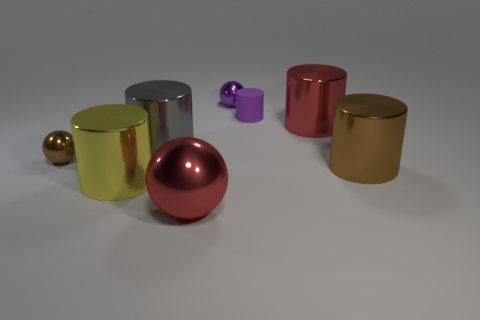What number of objects are either big gray things or big cylinders left of the purple shiny object?
Ensure brevity in your answer.  2. Are the sphere in front of the large brown metal cylinder and the purple cylinder made of the same material?
Offer a very short reply. No. What is the color of the shiny ball that is the same size as the yellow object?
Give a very brief answer. Red. Are there any red metal objects that have the same shape as the large gray object?
Your answer should be compact. Yes. There is a big cylinder that is in front of the brown metal object to the right of the ball that is in front of the yellow metal object; what color is it?
Offer a terse response. Yellow. How many shiny things are either brown cylinders or tiny brown things?
Your answer should be very brief. 2. Are there more big red metallic things in front of the small brown ball than large yellow metal cylinders behind the yellow metal thing?
Provide a short and direct response. Yes. What number of other things are there of the same size as the matte cylinder?
Keep it short and to the point. 2. There is a thing in front of the cylinder that is on the left side of the gray metallic cylinder; what size is it?
Your answer should be compact. Large. What number of tiny objects are either gray shiny cylinders or purple things?
Offer a terse response. 2. 